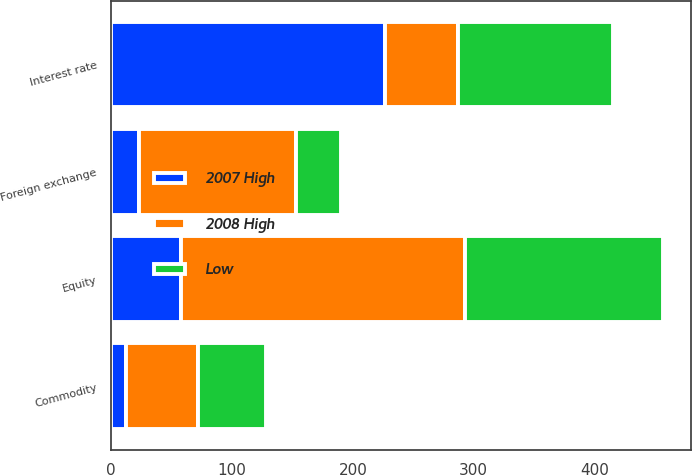Convert chart to OTSL. <chart><loc_0><loc_0><loc_500><loc_500><stacked_bar_chart><ecel><fcel>Interest rate<fcel>Foreign exchange<fcel>Equity<fcel>Commodity<nl><fcel>2007 High<fcel>227<fcel>23<fcel>58<fcel>12<nl><fcel>2008 High<fcel>60<fcel>130<fcel>235<fcel>60<nl><fcel>Low<fcel>128<fcel>37<fcel>164<fcel>56<nl></chart> 